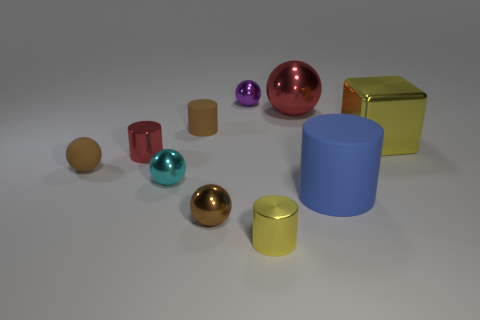Is there any other thing that is the same shape as the big yellow object?
Keep it short and to the point. No. What is the shape of the tiny red thing?
Provide a short and direct response. Cylinder. There is a small object behind the big red thing; does it have the same shape as the cyan metal thing?
Provide a short and direct response. Yes. Is the number of small red shiny cylinders that are to the left of the block greater than the number of tiny objects to the right of the big rubber cylinder?
Give a very brief answer. Yes. How many other things are the same size as the brown metallic thing?
Your response must be concise. 6. Is the shape of the large blue thing the same as the matte object to the left of the small matte cylinder?
Make the answer very short. No. How many metal things are big cylinders or purple cylinders?
Your answer should be compact. 0. Are there any big balls of the same color as the large block?
Your answer should be compact. No. Are there any large green shiny things?
Offer a terse response. No. Do the big red shiny object and the small yellow object have the same shape?
Your answer should be very brief. No. 